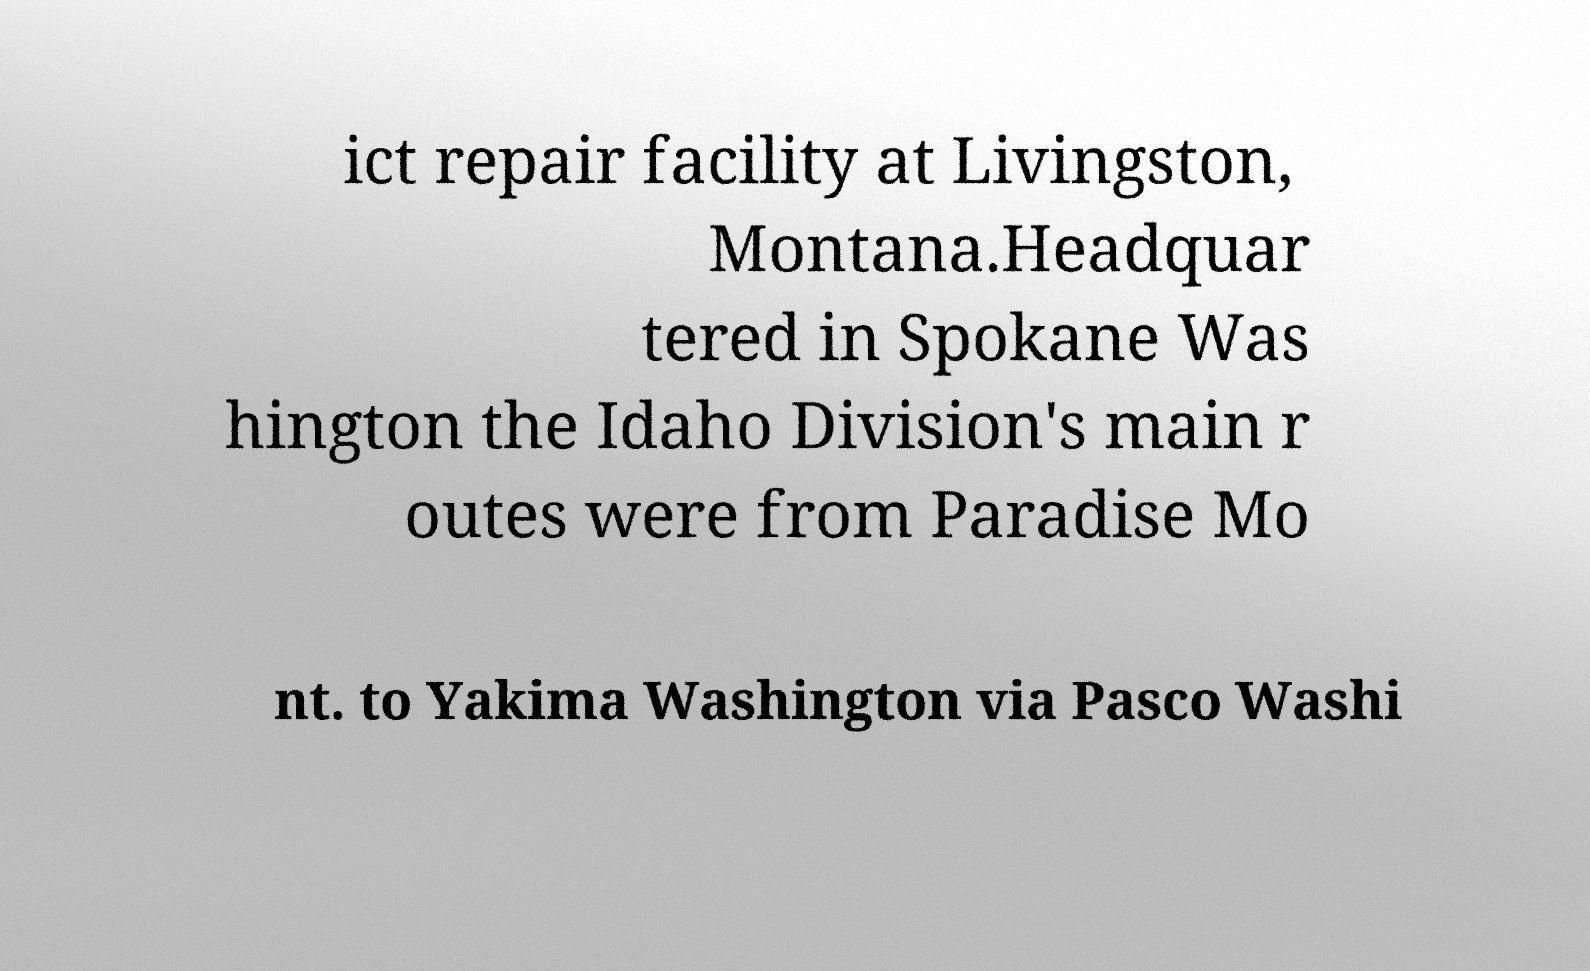For documentation purposes, I need the text within this image transcribed. Could you provide that? ict repair facility at Livingston, Montana.Headquar tered in Spokane Was hington the Idaho Division's main r outes were from Paradise Mo nt. to Yakima Washington via Pasco Washi 